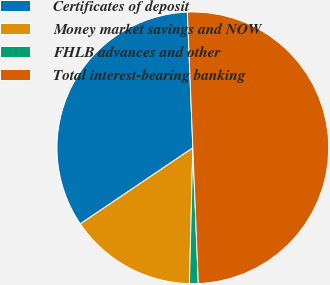Convert chart. <chart><loc_0><loc_0><loc_500><loc_500><pie_chart><fcel>Certificates of deposit<fcel>Money market savings and NOW<fcel>FHLB advances and other<fcel>Total interest-bearing banking<nl><fcel>33.82%<fcel>15.14%<fcel>1.04%<fcel>50.0%<nl></chart> 